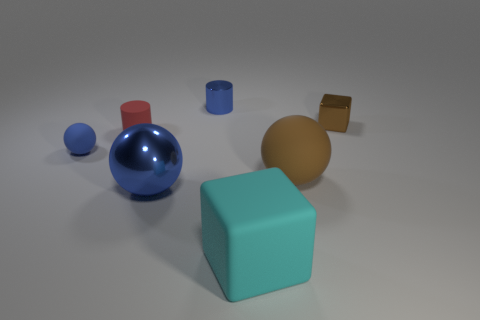Add 2 metallic cylinders. How many objects exist? 9 Add 4 large brown cylinders. How many large brown cylinders exist? 4 Subtract 0 green cubes. How many objects are left? 7 Subtract all spheres. How many objects are left? 4 Subtract all tiny red metal spheres. Subtract all tiny blue metallic things. How many objects are left? 6 Add 6 large brown things. How many large brown things are left? 7 